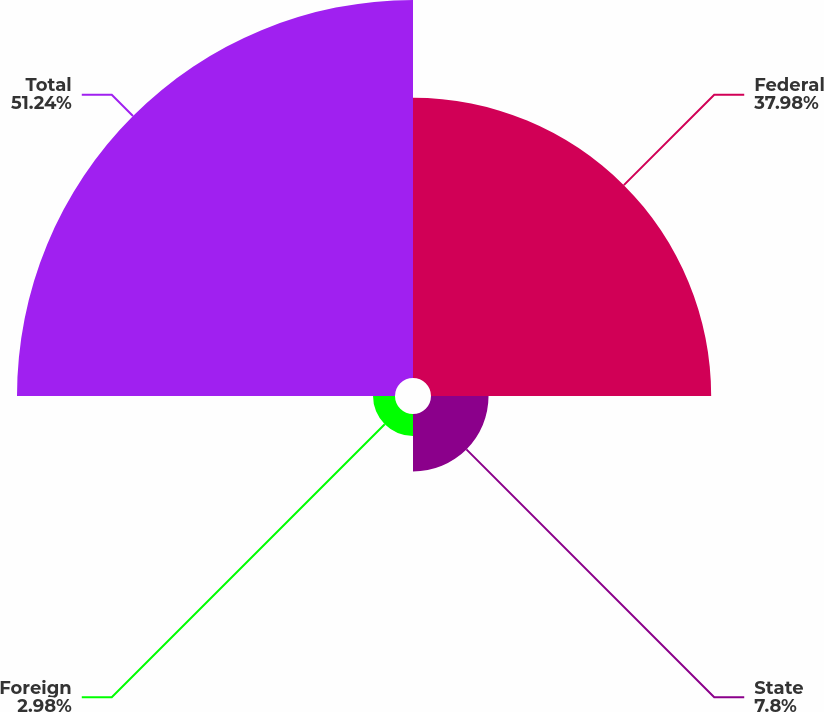Convert chart. <chart><loc_0><loc_0><loc_500><loc_500><pie_chart><fcel>Federal<fcel>State<fcel>Foreign<fcel>Total<nl><fcel>37.98%<fcel>7.8%<fcel>2.98%<fcel>51.24%<nl></chart> 